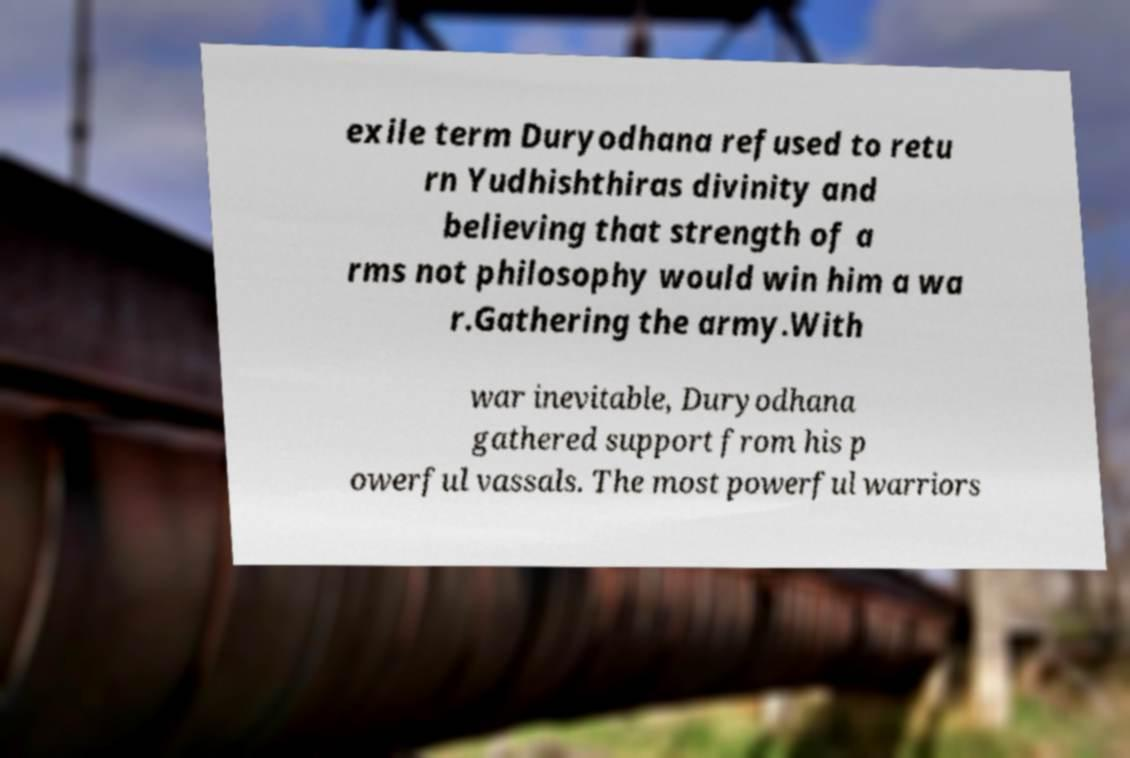I need the written content from this picture converted into text. Can you do that? exile term Duryodhana refused to retu rn Yudhishthiras divinity and believing that strength of a rms not philosophy would win him a wa r.Gathering the army.With war inevitable, Duryodhana gathered support from his p owerful vassals. The most powerful warriors 